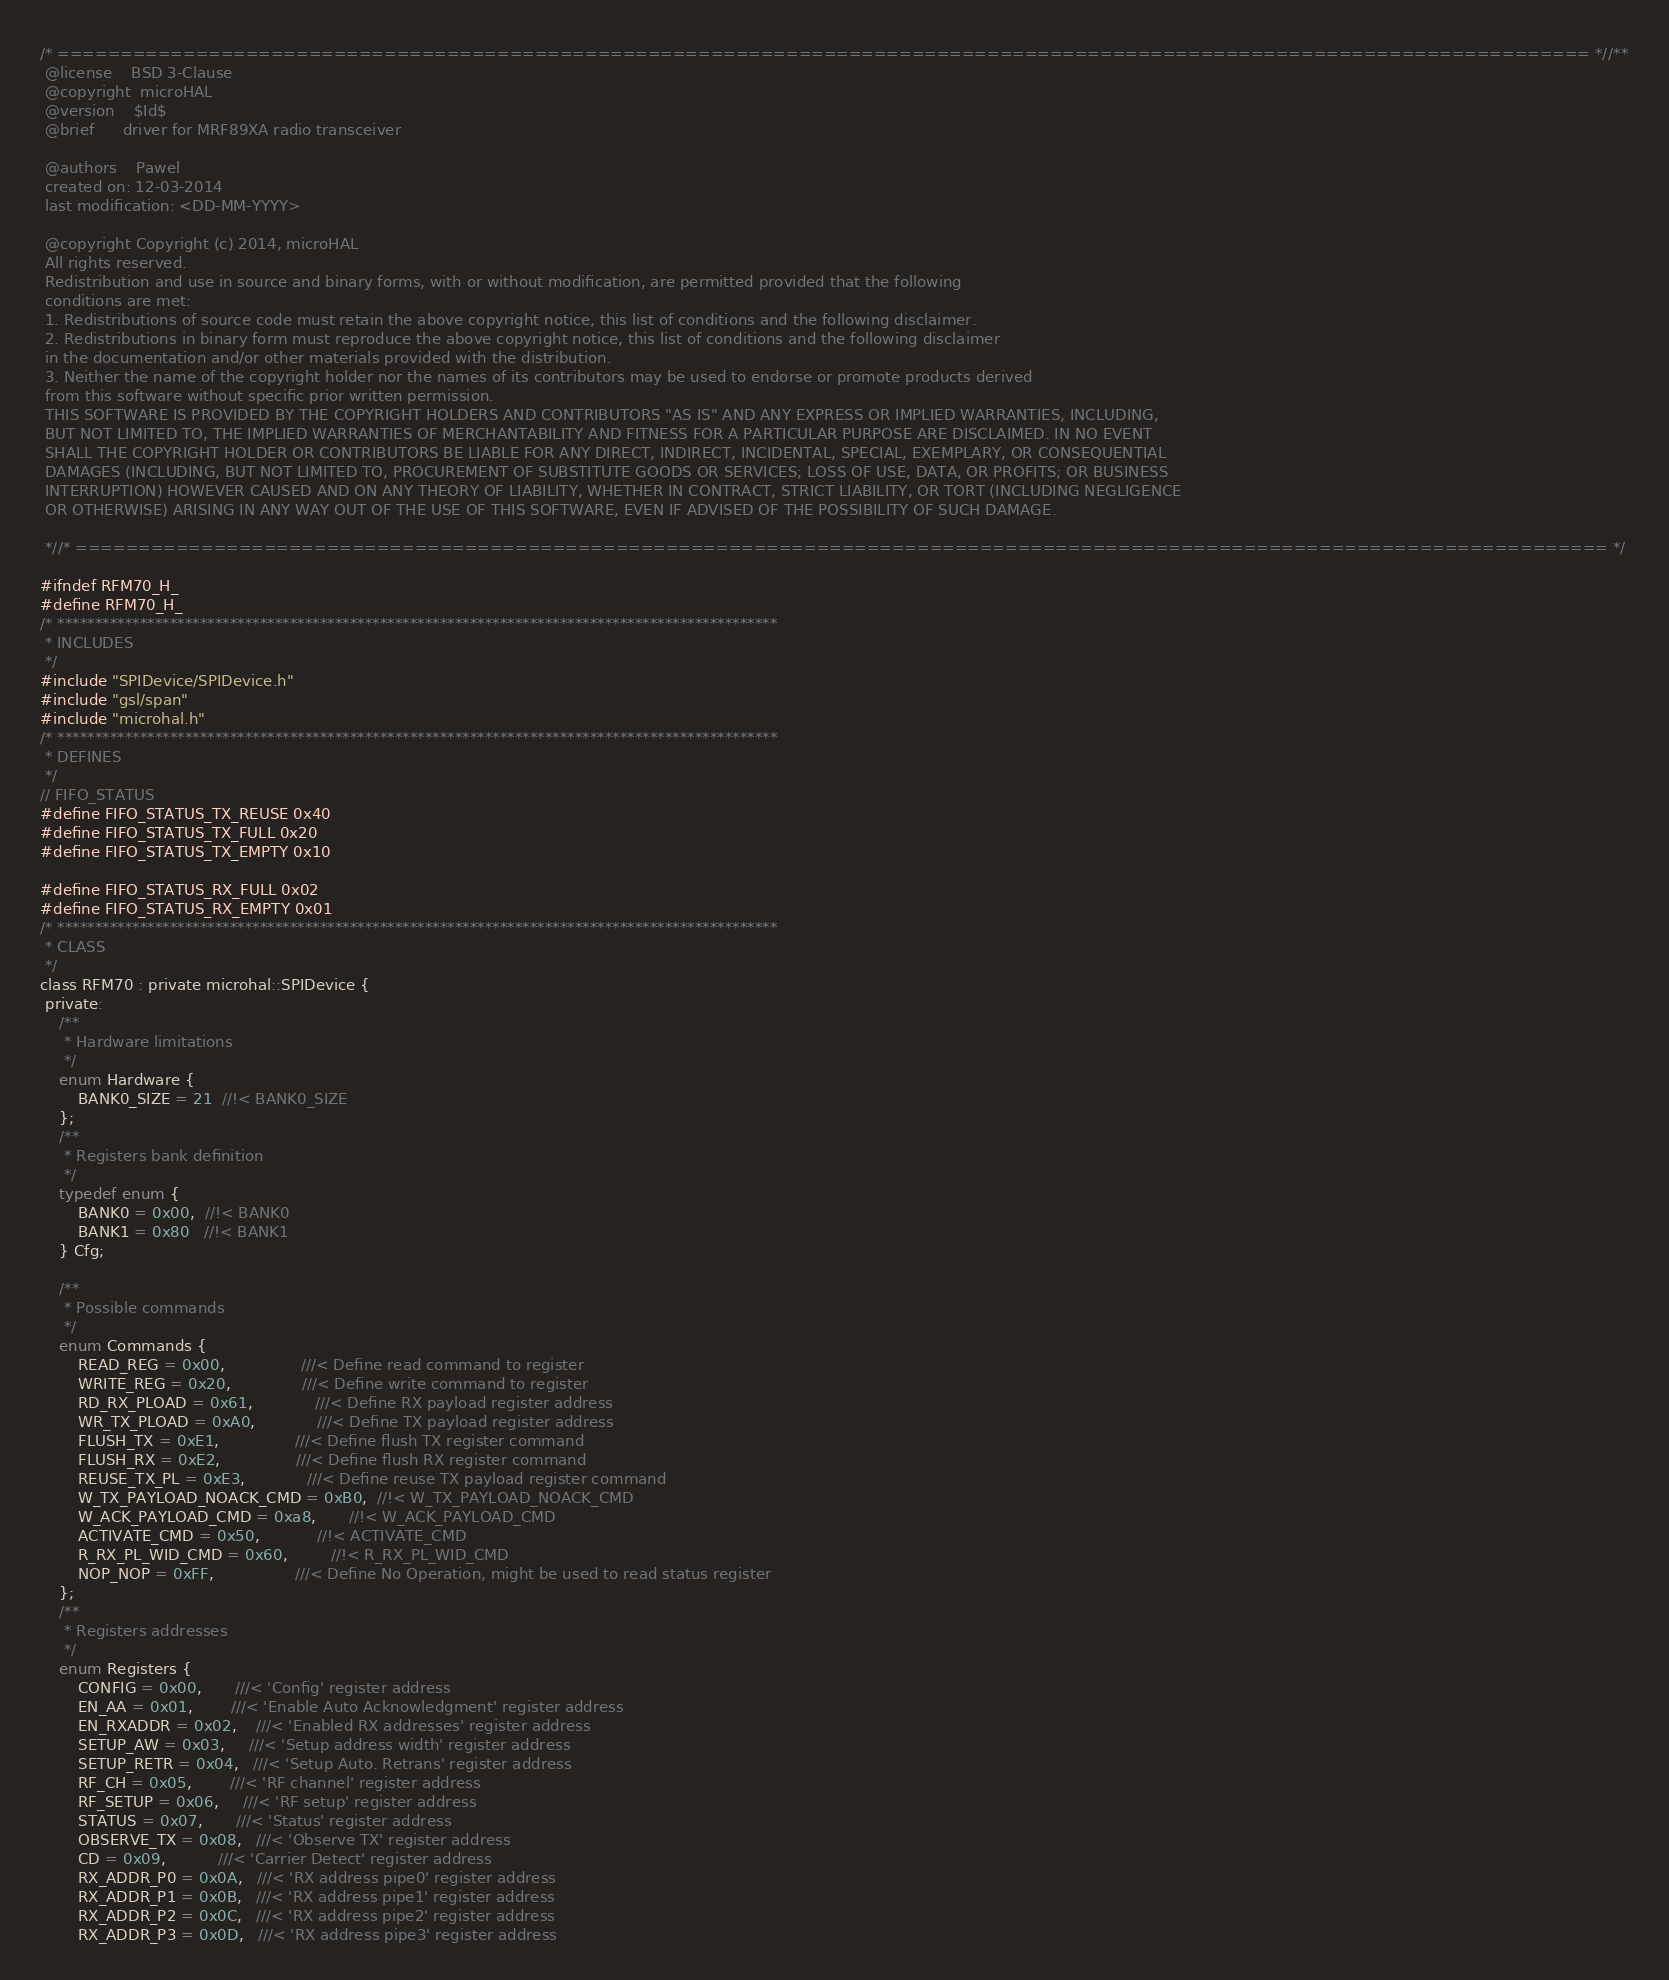Convert code to text. <code><loc_0><loc_0><loc_500><loc_500><_C_>/* ========================================================================================================================== *//**
 @license    BSD 3-Clause
 @copyright  microHAL
 @version    $Id$
 @brief      driver for MRF89XA radio transceiver

 @authors    Pawel
 created on: 12-03-2014
 last modification: <DD-MM-YYYY>

 @copyright Copyright (c) 2014, microHAL
 All rights reserved.
 Redistribution and use in source and binary forms, with or without modification, are permitted provided that the following
 conditions are met:
 1. Redistributions of source code must retain the above copyright notice, this list of conditions and the following disclaimer.
 2. Redistributions in binary form must reproduce the above copyright notice, this list of conditions and the following disclaimer
 in the documentation and/or other materials provided with the distribution.
 3. Neither the name of the copyright holder nor the names of its contributors may be used to endorse or promote products derived
 from this software without specific prior written permission.
 THIS SOFTWARE IS PROVIDED BY THE COPYRIGHT HOLDERS AND CONTRIBUTORS "AS IS" AND ANY EXPRESS OR IMPLIED WARRANTIES, INCLUDING,
 BUT NOT LIMITED TO, THE IMPLIED WARRANTIES OF MERCHANTABILITY AND FITNESS FOR A PARTICULAR PURPOSE ARE DISCLAIMED. IN NO EVENT
 SHALL THE COPYRIGHT HOLDER OR CONTRIBUTORS BE LIABLE FOR ANY DIRECT, INDIRECT, INCIDENTAL, SPECIAL, EXEMPLARY, OR CONSEQUENTIAL
 DAMAGES (INCLUDING, BUT NOT LIMITED TO, PROCUREMENT OF SUBSTITUTE GOODS OR SERVICES; LOSS OF USE, DATA, OR PROFITS; OR BUSINESS
 INTERRUPTION) HOWEVER CAUSED AND ON ANY THEORY OF LIABILITY, WHETHER IN CONTRACT, STRICT LIABILITY, OR TORT (INCLUDING NEGLIGENCE
 OR OTHERWISE) ARISING IN ANY WAY OUT OF THE USE OF THIS SOFTWARE, EVEN IF ADVISED OF THE POSSIBILITY OF SUCH DAMAGE.

 *//* ========================================================================================================================== */

#ifndef RFM70_H_
#define RFM70_H_
/* ************************************************************************************************
 * INCLUDES
 */
#include "SPIDevice/SPIDevice.h"
#include "gsl/span"
#include "microhal.h"
/* ************************************************************************************************
 * DEFINES
 */
// FIFO_STATUS
#define FIFO_STATUS_TX_REUSE 0x40
#define FIFO_STATUS_TX_FULL 0x20
#define FIFO_STATUS_TX_EMPTY 0x10

#define FIFO_STATUS_RX_FULL 0x02
#define FIFO_STATUS_RX_EMPTY 0x01
/* ************************************************************************************************
 * CLASS
 */
class RFM70 : private microhal::SPIDevice {
 private:
    /**
     * Hardware limitations
     */
    enum Hardware {
        BANK0_SIZE = 21  //!< BANK0_SIZE
    };
    /**
     * Registers bank definition
     */
    typedef enum {
        BANK0 = 0x00,  //!< BANK0
        BANK1 = 0x80   //!< BANK1
    } Cfg;

    /**
     * Possible commands
     */
    enum Commands {
        READ_REG = 0x00,                ///< Define read command to register
        WRITE_REG = 0x20,               ///< Define write command to register
        RD_RX_PLOAD = 0x61,             ///< Define RX payload register address
        WR_TX_PLOAD = 0xA0,             ///< Define TX payload register address
        FLUSH_TX = 0xE1,                ///< Define flush TX register command
        FLUSH_RX = 0xE2,                ///< Define flush RX register command
        REUSE_TX_PL = 0xE3,             ///< Define reuse TX payload register command
        W_TX_PAYLOAD_NOACK_CMD = 0xB0,  //!< W_TX_PAYLOAD_NOACK_CMD
        W_ACK_PAYLOAD_CMD = 0xa8,       //!< W_ACK_PAYLOAD_CMD
        ACTIVATE_CMD = 0x50,            //!< ACTIVATE_CMD
        R_RX_PL_WID_CMD = 0x60,         //!< R_RX_PL_WID_CMD
        NOP_NOP = 0xFF,                 ///< Define No Operation, might be used to read status register
    };
    /**
     * Registers addresses
     */
    enum Registers {
        CONFIG = 0x00,       ///< 'Config' register address
        EN_AA = 0x01,        ///< 'Enable Auto Acknowledgment' register address
        EN_RXADDR = 0x02,    ///< 'Enabled RX addresses' register address
        SETUP_AW = 0x03,     ///< 'Setup address width' register address
        SETUP_RETR = 0x04,   ///< 'Setup Auto. Retrans' register address
        RF_CH = 0x05,        ///< 'RF channel' register address
        RF_SETUP = 0x06,     ///< 'RF setup' register address
        STATUS = 0x07,       ///< 'Status' register address
        OBSERVE_TX = 0x08,   ///< 'Observe TX' register address
        CD = 0x09,           ///< 'Carrier Detect' register address
        RX_ADDR_P0 = 0x0A,   ///< 'RX address pipe0' register address
        RX_ADDR_P1 = 0x0B,   ///< 'RX address pipe1' register address
        RX_ADDR_P2 = 0x0C,   ///< 'RX address pipe2' register address
        RX_ADDR_P3 = 0x0D,   ///< 'RX address pipe3' register address</code> 